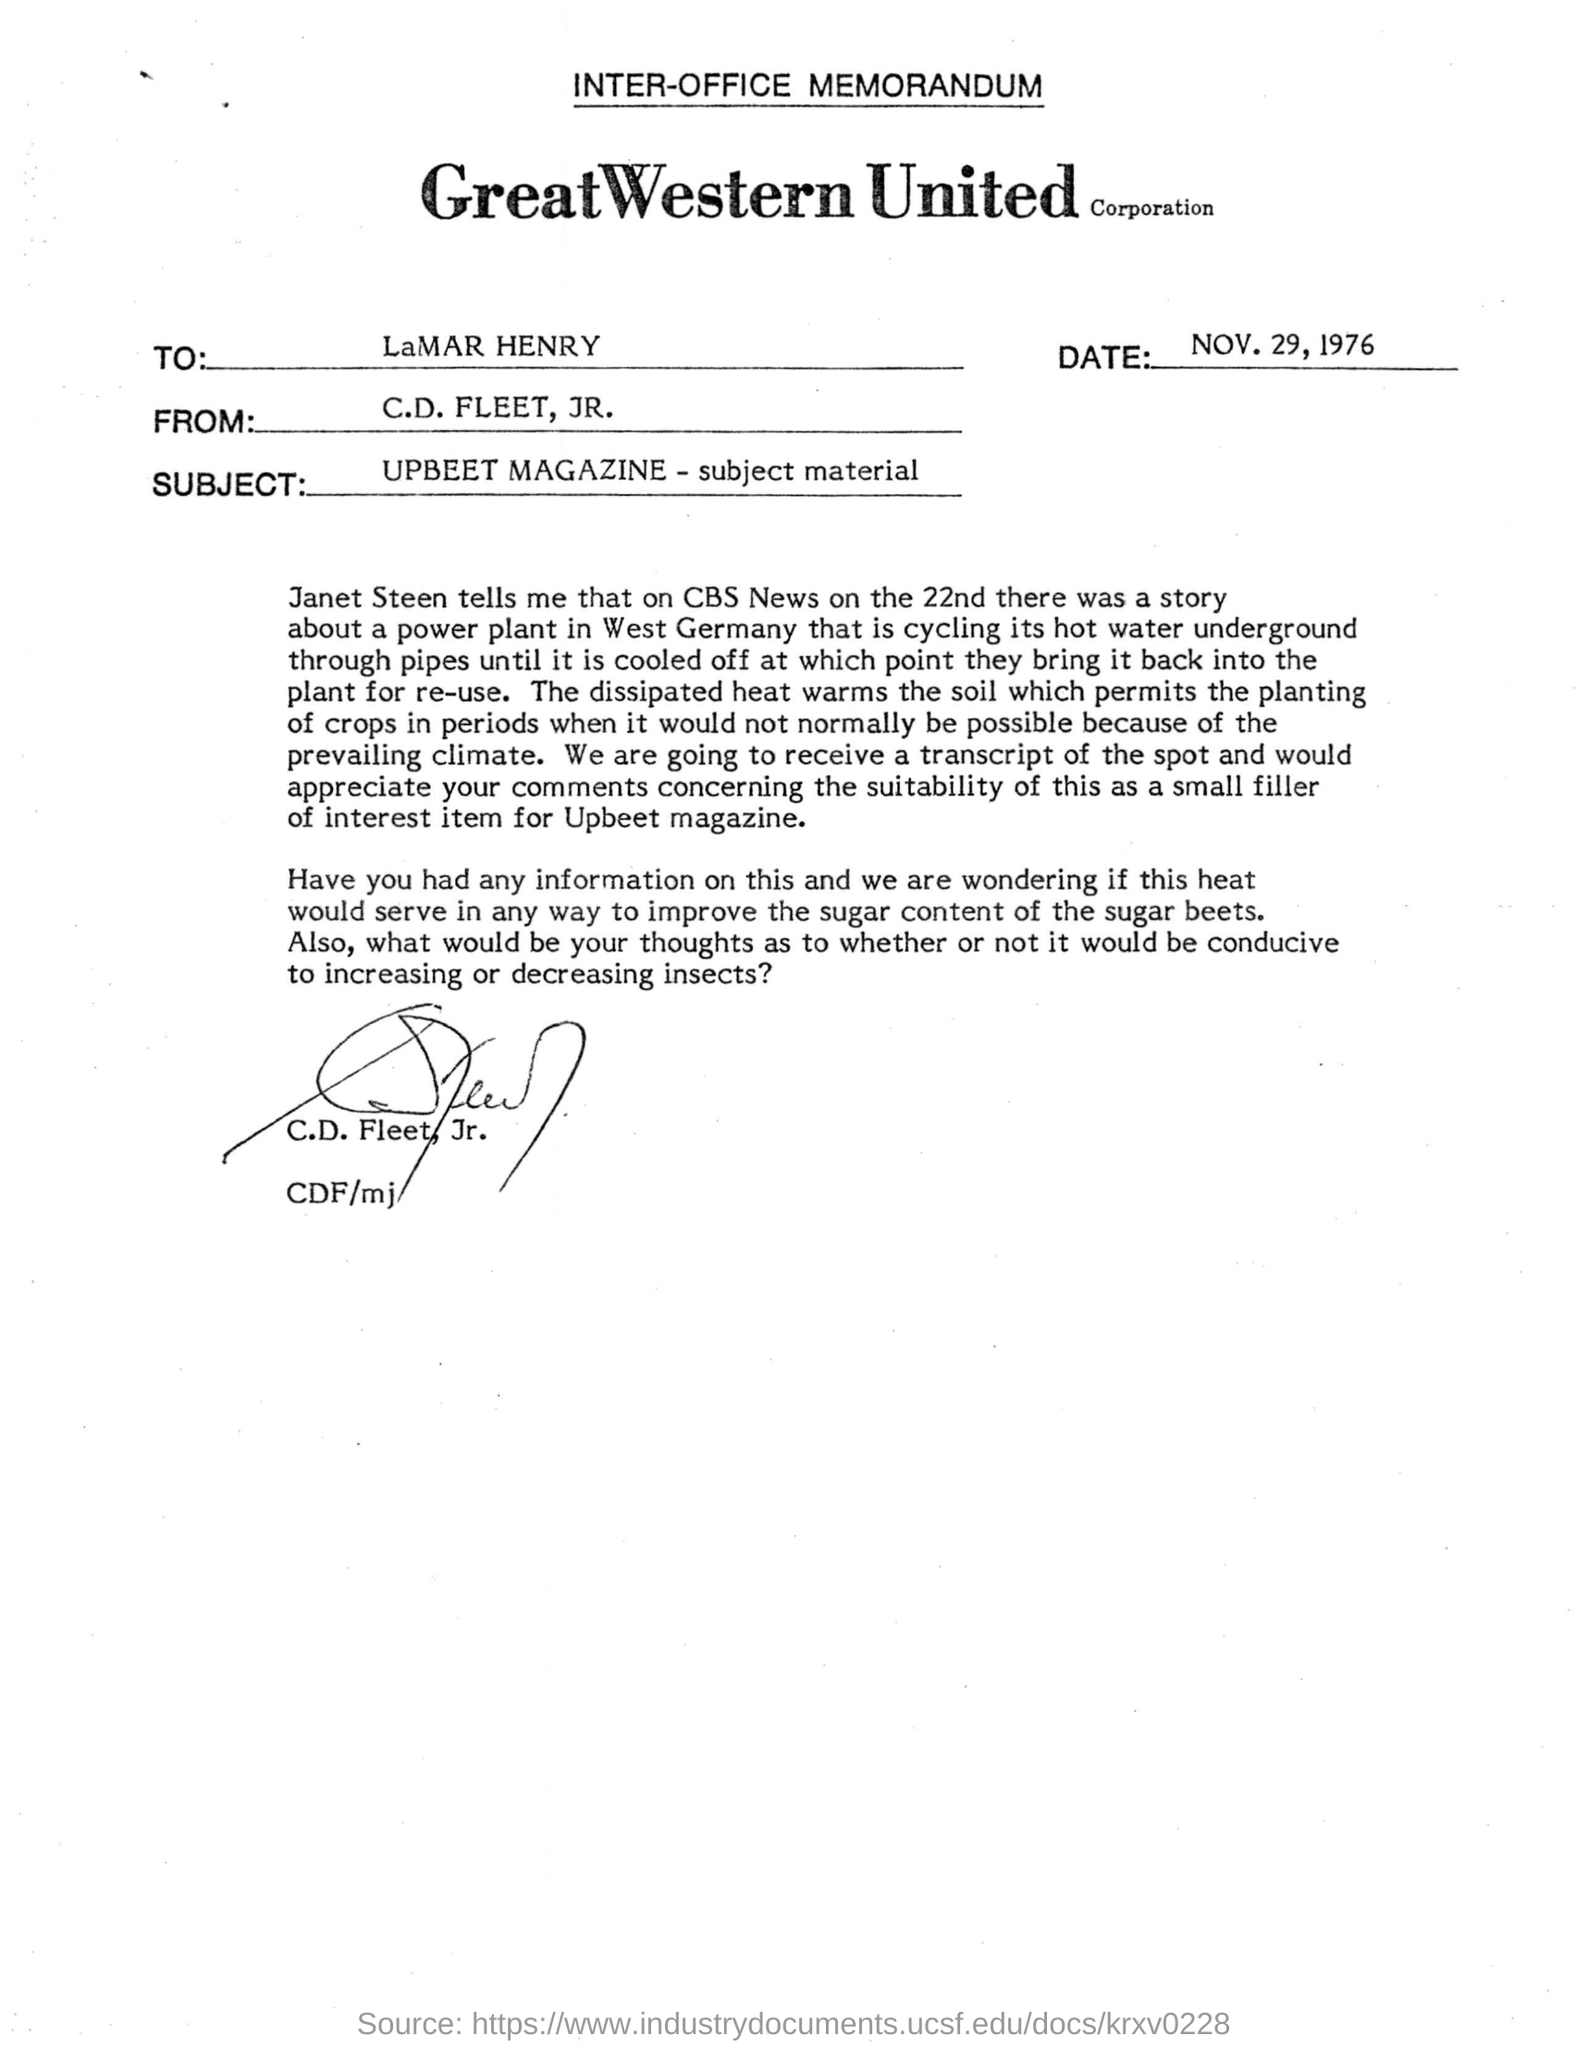To whom is the letter written?
Your answer should be compact. LaMAR HENRY. Where is this letter extracted from?
Your response must be concise. UPBEET MAGAZINE. What is the subject of this memorandum?
Offer a terse response. UPBEET MAGAZINE - subject material. Who has signed this memorandum?
Make the answer very short. C.D. Fleet, Jr. 